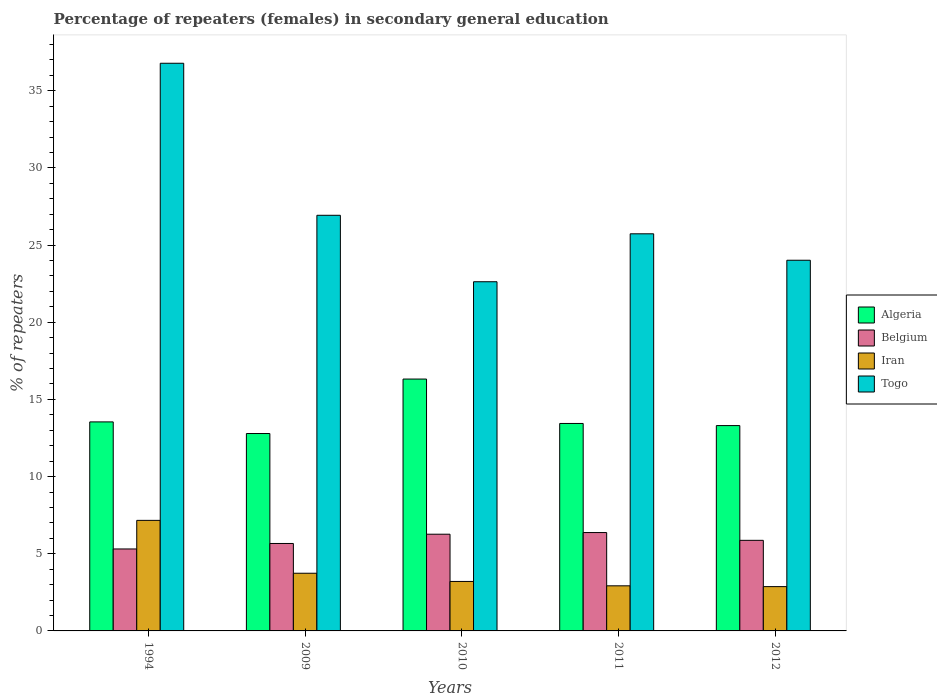How many different coloured bars are there?
Your answer should be very brief. 4. How many bars are there on the 2nd tick from the left?
Your response must be concise. 4. How many bars are there on the 5th tick from the right?
Give a very brief answer. 4. What is the percentage of female repeaters in Togo in 2010?
Your answer should be compact. 22.62. Across all years, what is the maximum percentage of female repeaters in Togo?
Make the answer very short. 36.78. Across all years, what is the minimum percentage of female repeaters in Togo?
Offer a very short reply. 22.62. What is the total percentage of female repeaters in Belgium in the graph?
Provide a short and direct response. 29.49. What is the difference between the percentage of female repeaters in Togo in 2010 and that in 2012?
Your answer should be very brief. -1.39. What is the difference between the percentage of female repeaters in Iran in 2011 and the percentage of female repeaters in Algeria in 1994?
Offer a terse response. -10.62. What is the average percentage of female repeaters in Iran per year?
Your answer should be compact. 3.98. In the year 2010, what is the difference between the percentage of female repeaters in Algeria and percentage of female repeaters in Togo?
Keep it short and to the point. -6.31. In how many years, is the percentage of female repeaters in Algeria greater than 29 %?
Provide a short and direct response. 0. What is the ratio of the percentage of female repeaters in Iran in 2010 to that in 2011?
Your answer should be very brief. 1.1. Is the difference between the percentage of female repeaters in Algeria in 2011 and 2012 greater than the difference between the percentage of female repeaters in Togo in 2011 and 2012?
Give a very brief answer. No. What is the difference between the highest and the second highest percentage of female repeaters in Togo?
Offer a very short reply. 9.85. What is the difference between the highest and the lowest percentage of female repeaters in Belgium?
Provide a succinct answer. 1.06. Is the sum of the percentage of female repeaters in Togo in 1994 and 2011 greater than the maximum percentage of female repeaters in Belgium across all years?
Your answer should be compact. Yes. Is it the case that in every year, the sum of the percentage of female repeaters in Algeria and percentage of female repeaters in Togo is greater than the sum of percentage of female repeaters in Belgium and percentage of female repeaters in Iran?
Your answer should be compact. No. What does the 4th bar from the left in 2010 represents?
Your answer should be very brief. Togo. What does the 2nd bar from the right in 1994 represents?
Make the answer very short. Iran. How many legend labels are there?
Offer a very short reply. 4. What is the title of the graph?
Your answer should be very brief. Percentage of repeaters (females) in secondary general education. Does "Caribbean small states" appear as one of the legend labels in the graph?
Give a very brief answer. No. What is the label or title of the Y-axis?
Offer a terse response. % of repeaters. What is the % of repeaters of Algeria in 1994?
Your answer should be very brief. 13.54. What is the % of repeaters in Belgium in 1994?
Provide a short and direct response. 5.31. What is the % of repeaters in Iran in 1994?
Provide a succinct answer. 7.16. What is the % of repeaters in Togo in 1994?
Offer a very short reply. 36.78. What is the % of repeaters of Algeria in 2009?
Your answer should be compact. 12.79. What is the % of repeaters of Belgium in 2009?
Ensure brevity in your answer.  5.67. What is the % of repeaters in Iran in 2009?
Ensure brevity in your answer.  3.74. What is the % of repeaters in Togo in 2009?
Offer a terse response. 26.93. What is the % of repeaters in Algeria in 2010?
Your answer should be compact. 16.32. What is the % of repeaters of Belgium in 2010?
Provide a succinct answer. 6.27. What is the % of repeaters in Iran in 2010?
Offer a very short reply. 3.21. What is the % of repeaters in Togo in 2010?
Your answer should be very brief. 22.62. What is the % of repeaters of Algeria in 2011?
Offer a terse response. 13.44. What is the % of repeaters in Belgium in 2011?
Your response must be concise. 6.37. What is the % of repeaters of Iran in 2011?
Keep it short and to the point. 2.92. What is the % of repeaters of Togo in 2011?
Provide a succinct answer. 25.73. What is the % of repeaters of Algeria in 2012?
Your answer should be very brief. 13.3. What is the % of repeaters of Belgium in 2012?
Provide a succinct answer. 5.87. What is the % of repeaters of Iran in 2012?
Provide a succinct answer. 2.87. What is the % of repeaters of Togo in 2012?
Give a very brief answer. 24.02. Across all years, what is the maximum % of repeaters in Algeria?
Offer a terse response. 16.32. Across all years, what is the maximum % of repeaters of Belgium?
Your answer should be compact. 6.37. Across all years, what is the maximum % of repeaters in Iran?
Your answer should be compact. 7.16. Across all years, what is the maximum % of repeaters in Togo?
Ensure brevity in your answer.  36.78. Across all years, what is the minimum % of repeaters of Algeria?
Make the answer very short. 12.79. Across all years, what is the minimum % of repeaters of Belgium?
Your response must be concise. 5.31. Across all years, what is the minimum % of repeaters of Iran?
Offer a very short reply. 2.87. Across all years, what is the minimum % of repeaters of Togo?
Your answer should be very brief. 22.62. What is the total % of repeaters in Algeria in the graph?
Keep it short and to the point. 69.4. What is the total % of repeaters in Belgium in the graph?
Your answer should be compact. 29.49. What is the total % of repeaters in Iran in the graph?
Keep it short and to the point. 19.9. What is the total % of repeaters in Togo in the graph?
Your answer should be compact. 136.08. What is the difference between the % of repeaters of Algeria in 1994 and that in 2009?
Make the answer very short. 0.75. What is the difference between the % of repeaters in Belgium in 1994 and that in 2009?
Give a very brief answer. -0.36. What is the difference between the % of repeaters of Iran in 1994 and that in 2009?
Offer a terse response. 3.43. What is the difference between the % of repeaters of Togo in 1994 and that in 2009?
Ensure brevity in your answer.  9.85. What is the difference between the % of repeaters of Algeria in 1994 and that in 2010?
Keep it short and to the point. -2.78. What is the difference between the % of repeaters in Belgium in 1994 and that in 2010?
Offer a very short reply. -0.96. What is the difference between the % of repeaters of Iran in 1994 and that in 2010?
Offer a terse response. 3.96. What is the difference between the % of repeaters of Togo in 1994 and that in 2010?
Provide a short and direct response. 14.16. What is the difference between the % of repeaters of Algeria in 1994 and that in 2011?
Give a very brief answer. 0.1. What is the difference between the % of repeaters in Belgium in 1994 and that in 2011?
Your answer should be very brief. -1.06. What is the difference between the % of repeaters in Iran in 1994 and that in 2011?
Provide a short and direct response. 4.24. What is the difference between the % of repeaters of Togo in 1994 and that in 2011?
Give a very brief answer. 11.05. What is the difference between the % of repeaters in Algeria in 1994 and that in 2012?
Make the answer very short. 0.24. What is the difference between the % of repeaters of Belgium in 1994 and that in 2012?
Your answer should be compact. -0.56. What is the difference between the % of repeaters of Iran in 1994 and that in 2012?
Keep it short and to the point. 4.29. What is the difference between the % of repeaters in Togo in 1994 and that in 2012?
Offer a terse response. 12.76. What is the difference between the % of repeaters in Algeria in 2009 and that in 2010?
Offer a very short reply. -3.53. What is the difference between the % of repeaters in Belgium in 2009 and that in 2010?
Ensure brevity in your answer.  -0.6. What is the difference between the % of repeaters of Iran in 2009 and that in 2010?
Provide a succinct answer. 0.53. What is the difference between the % of repeaters in Togo in 2009 and that in 2010?
Provide a short and direct response. 4.31. What is the difference between the % of repeaters of Algeria in 2009 and that in 2011?
Give a very brief answer. -0.65. What is the difference between the % of repeaters of Belgium in 2009 and that in 2011?
Offer a terse response. -0.71. What is the difference between the % of repeaters of Iran in 2009 and that in 2011?
Your answer should be compact. 0.82. What is the difference between the % of repeaters of Algeria in 2009 and that in 2012?
Give a very brief answer. -0.51. What is the difference between the % of repeaters of Belgium in 2009 and that in 2012?
Make the answer very short. -0.2. What is the difference between the % of repeaters in Iran in 2009 and that in 2012?
Keep it short and to the point. 0.87. What is the difference between the % of repeaters of Togo in 2009 and that in 2012?
Keep it short and to the point. 2.91. What is the difference between the % of repeaters of Algeria in 2010 and that in 2011?
Provide a succinct answer. 2.88. What is the difference between the % of repeaters in Belgium in 2010 and that in 2011?
Your answer should be very brief. -0.11. What is the difference between the % of repeaters of Iran in 2010 and that in 2011?
Offer a terse response. 0.28. What is the difference between the % of repeaters in Togo in 2010 and that in 2011?
Your response must be concise. -3.11. What is the difference between the % of repeaters in Algeria in 2010 and that in 2012?
Your answer should be compact. 3.01. What is the difference between the % of repeaters in Belgium in 2010 and that in 2012?
Keep it short and to the point. 0.4. What is the difference between the % of repeaters of Iran in 2010 and that in 2012?
Provide a short and direct response. 0.34. What is the difference between the % of repeaters in Togo in 2010 and that in 2012?
Your response must be concise. -1.39. What is the difference between the % of repeaters in Algeria in 2011 and that in 2012?
Give a very brief answer. 0.14. What is the difference between the % of repeaters in Belgium in 2011 and that in 2012?
Give a very brief answer. 0.5. What is the difference between the % of repeaters of Iran in 2011 and that in 2012?
Provide a short and direct response. 0.05. What is the difference between the % of repeaters in Togo in 2011 and that in 2012?
Give a very brief answer. 1.71. What is the difference between the % of repeaters of Algeria in 1994 and the % of repeaters of Belgium in 2009?
Your answer should be compact. 7.88. What is the difference between the % of repeaters of Algeria in 1994 and the % of repeaters of Iran in 2009?
Your response must be concise. 9.81. What is the difference between the % of repeaters in Algeria in 1994 and the % of repeaters in Togo in 2009?
Make the answer very short. -13.39. What is the difference between the % of repeaters in Belgium in 1994 and the % of repeaters in Iran in 2009?
Provide a succinct answer. 1.57. What is the difference between the % of repeaters in Belgium in 1994 and the % of repeaters in Togo in 2009?
Your answer should be very brief. -21.62. What is the difference between the % of repeaters of Iran in 1994 and the % of repeaters of Togo in 2009?
Your response must be concise. -19.77. What is the difference between the % of repeaters in Algeria in 1994 and the % of repeaters in Belgium in 2010?
Your response must be concise. 7.28. What is the difference between the % of repeaters of Algeria in 1994 and the % of repeaters of Iran in 2010?
Provide a short and direct response. 10.34. What is the difference between the % of repeaters in Algeria in 1994 and the % of repeaters in Togo in 2010?
Provide a short and direct response. -9.08. What is the difference between the % of repeaters in Belgium in 1994 and the % of repeaters in Iran in 2010?
Your answer should be compact. 2.1. What is the difference between the % of repeaters in Belgium in 1994 and the % of repeaters in Togo in 2010?
Provide a short and direct response. -17.31. What is the difference between the % of repeaters of Iran in 1994 and the % of repeaters of Togo in 2010?
Offer a very short reply. -15.46. What is the difference between the % of repeaters in Algeria in 1994 and the % of repeaters in Belgium in 2011?
Ensure brevity in your answer.  7.17. What is the difference between the % of repeaters in Algeria in 1994 and the % of repeaters in Iran in 2011?
Your response must be concise. 10.62. What is the difference between the % of repeaters in Algeria in 1994 and the % of repeaters in Togo in 2011?
Your answer should be compact. -12.19. What is the difference between the % of repeaters in Belgium in 1994 and the % of repeaters in Iran in 2011?
Offer a very short reply. 2.39. What is the difference between the % of repeaters in Belgium in 1994 and the % of repeaters in Togo in 2011?
Your answer should be compact. -20.42. What is the difference between the % of repeaters in Iran in 1994 and the % of repeaters in Togo in 2011?
Give a very brief answer. -18.57. What is the difference between the % of repeaters in Algeria in 1994 and the % of repeaters in Belgium in 2012?
Your answer should be compact. 7.67. What is the difference between the % of repeaters in Algeria in 1994 and the % of repeaters in Iran in 2012?
Your answer should be compact. 10.67. What is the difference between the % of repeaters in Algeria in 1994 and the % of repeaters in Togo in 2012?
Provide a succinct answer. -10.47. What is the difference between the % of repeaters in Belgium in 1994 and the % of repeaters in Iran in 2012?
Your answer should be compact. 2.44. What is the difference between the % of repeaters of Belgium in 1994 and the % of repeaters of Togo in 2012?
Provide a short and direct response. -18.71. What is the difference between the % of repeaters of Iran in 1994 and the % of repeaters of Togo in 2012?
Provide a short and direct response. -16.85. What is the difference between the % of repeaters of Algeria in 2009 and the % of repeaters of Belgium in 2010?
Make the answer very short. 6.52. What is the difference between the % of repeaters in Algeria in 2009 and the % of repeaters in Iran in 2010?
Your response must be concise. 9.58. What is the difference between the % of repeaters of Algeria in 2009 and the % of repeaters of Togo in 2010?
Your answer should be compact. -9.83. What is the difference between the % of repeaters in Belgium in 2009 and the % of repeaters in Iran in 2010?
Offer a very short reply. 2.46. What is the difference between the % of repeaters of Belgium in 2009 and the % of repeaters of Togo in 2010?
Ensure brevity in your answer.  -16.96. What is the difference between the % of repeaters in Iran in 2009 and the % of repeaters in Togo in 2010?
Your answer should be compact. -18.89. What is the difference between the % of repeaters of Algeria in 2009 and the % of repeaters of Belgium in 2011?
Keep it short and to the point. 6.42. What is the difference between the % of repeaters in Algeria in 2009 and the % of repeaters in Iran in 2011?
Your answer should be compact. 9.87. What is the difference between the % of repeaters of Algeria in 2009 and the % of repeaters of Togo in 2011?
Offer a very short reply. -12.94. What is the difference between the % of repeaters of Belgium in 2009 and the % of repeaters of Iran in 2011?
Give a very brief answer. 2.74. What is the difference between the % of repeaters of Belgium in 2009 and the % of repeaters of Togo in 2011?
Offer a very short reply. -20.06. What is the difference between the % of repeaters in Iran in 2009 and the % of repeaters in Togo in 2011?
Provide a succinct answer. -21.99. What is the difference between the % of repeaters in Algeria in 2009 and the % of repeaters in Belgium in 2012?
Your answer should be very brief. 6.92. What is the difference between the % of repeaters of Algeria in 2009 and the % of repeaters of Iran in 2012?
Your answer should be compact. 9.92. What is the difference between the % of repeaters in Algeria in 2009 and the % of repeaters in Togo in 2012?
Provide a short and direct response. -11.23. What is the difference between the % of repeaters in Belgium in 2009 and the % of repeaters in Iran in 2012?
Give a very brief answer. 2.8. What is the difference between the % of repeaters in Belgium in 2009 and the % of repeaters in Togo in 2012?
Offer a terse response. -18.35. What is the difference between the % of repeaters in Iran in 2009 and the % of repeaters in Togo in 2012?
Your answer should be compact. -20.28. What is the difference between the % of repeaters of Algeria in 2010 and the % of repeaters of Belgium in 2011?
Offer a terse response. 9.95. What is the difference between the % of repeaters of Algeria in 2010 and the % of repeaters of Iran in 2011?
Keep it short and to the point. 13.4. What is the difference between the % of repeaters in Algeria in 2010 and the % of repeaters in Togo in 2011?
Ensure brevity in your answer.  -9.41. What is the difference between the % of repeaters of Belgium in 2010 and the % of repeaters of Iran in 2011?
Offer a terse response. 3.34. What is the difference between the % of repeaters in Belgium in 2010 and the % of repeaters in Togo in 2011?
Your answer should be very brief. -19.46. What is the difference between the % of repeaters of Iran in 2010 and the % of repeaters of Togo in 2011?
Your answer should be compact. -22.52. What is the difference between the % of repeaters of Algeria in 2010 and the % of repeaters of Belgium in 2012?
Keep it short and to the point. 10.45. What is the difference between the % of repeaters in Algeria in 2010 and the % of repeaters in Iran in 2012?
Your response must be concise. 13.45. What is the difference between the % of repeaters in Algeria in 2010 and the % of repeaters in Togo in 2012?
Give a very brief answer. -7.7. What is the difference between the % of repeaters in Belgium in 2010 and the % of repeaters in Iran in 2012?
Ensure brevity in your answer.  3.4. What is the difference between the % of repeaters in Belgium in 2010 and the % of repeaters in Togo in 2012?
Offer a very short reply. -17.75. What is the difference between the % of repeaters in Iran in 2010 and the % of repeaters in Togo in 2012?
Offer a very short reply. -20.81. What is the difference between the % of repeaters of Algeria in 2011 and the % of repeaters of Belgium in 2012?
Keep it short and to the point. 7.57. What is the difference between the % of repeaters in Algeria in 2011 and the % of repeaters in Iran in 2012?
Offer a very short reply. 10.57. What is the difference between the % of repeaters of Algeria in 2011 and the % of repeaters of Togo in 2012?
Keep it short and to the point. -10.58. What is the difference between the % of repeaters in Belgium in 2011 and the % of repeaters in Iran in 2012?
Offer a terse response. 3.5. What is the difference between the % of repeaters in Belgium in 2011 and the % of repeaters in Togo in 2012?
Offer a very short reply. -17.64. What is the difference between the % of repeaters in Iran in 2011 and the % of repeaters in Togo in 2012?
Offer a very short reply. -21.1. What is the average % of repeaters of Algeria per year?
Provide a short and direct response. 13.88. What is the average % of repeaters in Belgium per year?
Provide a short and direct response. 5.9. What is the average % of repeaters of Iran per year?
Your answer should be very brief. 3.98. What is the average % of repeaters of Togo per year?
Keep it short and to the point. 27.22. In the year 1994, what is the difference between the % of repeaters of Algeria and % of repeaters of Belgium?
Keep it short and to the point. 8.23. In the year 1994, what is the difference between the % of repeaters of Algeria and % of repeaters of Iran?
Offer a terse response. 6.38. In the year 1994, what is the difference between the % of repeaters of Algeria and % of repeaters of Togo?
Give a very brief answer. -23.24. In the year 1994, what is the difference between the % of repeaters of Belgium and % of repeaters of Iran?
Your answer should be very brief. -1.85. In the year 1994, what is the difference between the % of repeaters in Belgium and % of repeaters in Togo?
Your response must be concise. -31.47. In the year 1994, what is the difference between the % of repeaters in Iran and % of repeaters in Togo?
Offer a very short reply. -29.62. In the year 2009, what is the difference between the % of repeaters in Algeria and % of repeaters in Belgium?
Offer a terse response. 7.12. In the year 2009, what is the difference between the % of repeaters of Algeria and % of repeaters of Iran?
Provide a succinct answer. 9.05. In the year 2009, what is the difference between the % of repeaters of Algeria and % of repeaters of Togo?
Your answer should be compact. -14.14. In the year 2009, what is the difference between the % of repeaters of Belgium and % of repeaters of Iran?
Provide a short and direct response. 1.93. In the year 2009, what is the difference between the % of repeaters in Belgium and % of repeaters in Togo?
Your response must be concise. -21.26. In the year 2009, what is the difference between the % of repeaters in Iran and % of repeaters in Togo?
Provide a short and direct response. -23.19. In the year 2010, what is the difference between the % of repeaters in Algeria and % of repeaters in Belgium?
Your response must be concise. 10.05. In the year 2010, what is the difference between the % of repeaters of Algeria and % of repeaters of Iran?
Your answer should be compact. 13.11. In the year 2010, what is the difference between the % of repeaters in Algeria and % of repeaters in Togo?
Offer a very short reply. -6.31. In the year 2010, what is the difference between the % of repeaters in Belgium and % of repeaters in Iran?
Your answer should be very brief. 3.06. In the year 2010, what is the difference between the % of repeaters in Belgium and % of repeaters in Togo?
Give a very brief answer. -16.36. In the year 2010, what is the difference between the % of repeaters of Iran and % of repeaters of Togo?
Keep it short and to the point. -19.42. In the year 2011, what is the difference between the % of repeaters of Algeria and % of repeaters of Belgium?
Offer a very short reply. 7.07. In the year 2011, what is the difference between the % of repeaters of Algeria and % of repeaters of Iran?
Ensure brevity in your answer.  10.52. In the year 2011, what is the difference between the % of repeaters of Algeria and % of repeaters of Togo?
Provide a short and direct response. -12.29. In the year 2011, what is the difference between the % of repeaters in Belgium and % of repeaters in Iran?
Provide a short and direct response. 3.45. In the year 2011, what is the difference between the % of repeaters in Belgium and % of repeaters in Togo?
Offer a terse response. -19.36. In the year 2011, what is the difference between the % of repeaters of Iran and % of repeaters of Togo?
Provide a succinct answer. -22.81. In the year 2012, what is the difference between the % of repeaters in Algeria and % of repeaters in Belgium?
Make the answer very short. 7.44. In the year 2012, what is the difference between the % of repeaters in Algeria and % of repeaters in Iran?
Offer a terse response. 10.43. In the year 2012, what is the difference between the % of repeaters of Algeria and % of repeaters of Togo?
Offer a terse response. -10.71. In the year 2012, what is the difference between the % of repeaters in Belgium and % of repeaters in Iran?
Provide a succinct answer. 3. In the year 2012, what is the difference between the % of repeaters of Belgium and % of repeaters of Togo?
Your answer should be compact. -18.15. In the year 2012, what is the difference between the % of repeaters of Iran and % of repeaters of Togo?
Provide a short and direct response. -21.15. What is the ratio of the % of repeaters of Algeria in 1994 to that in 2009?
Ensure brevity in your answer.  1.06. What is the ratio of the % of repeaters of Belgium in 1994 to that in 2009?
Provide a short and direct response. 0.94. What is the ratio of the % of repeaters of Iran in 1994 to that in 2009?
Give a very brief answer. 1.92. What is the ratio of the % of repeaters in Togo in 1994 to that in 2009?
Make the answer very short. 1.37. What is the ratio of the % of repeaters of Algeria in 1994 to that in 2010?
Ensure brevity in your answer.  0.83. What is the ratio of the % of repeaters of Belgium in 1994 to that in 2010?
Make the answer very short. 0.85. What is the ratio of the % of repeaters in Iran in 1994 to that in 2010?
Give a very brief answer. 2.23. What is the ratio of the % of repeaters of Togo in 1994 to that in 2010?
Give a very brief answer. 1.63. What is the ratio of the % of repeaters in Algeria in 1994 to that in 2011?
Keep it short and to the point. 1.01. What is the ratio of the % of repeaters of Belgium in 1994 to that in 2011?
Make the answer very short. 0.83. What is the ratio of the % of repeaters in Iran in 1994 to that in 2011?
Provide a succinct answer. 2.45. What is the ratio of the % of repeaters in Togo in 1994 to that in 2011?
Your answer should be compact. 1.43. What is the ratio of the % of repeaters in Algeria in 1994 to that in 2012?
Keep it short and to the point. 1.02. What is the ratio of the % of repeaters of Belgium in 1994 to that in 2012?
Your response must be concise. 0.9. What is the ratio of the % of repeaters of Iran in 1994 to that in 2012?
Make the answer very short. 2.5. What is the ratio of the % of repeaters of Togo in 1994 to that in 2012?
Offer a very short reply. 1.53. What is the ratio of the % of repeaters in Algeria in 2009 to that in 2010?
Provide a succinct answer. 0.78. What is the ratio of the % of repeaters of Belgium in 2009 to that in 2010?
Provide a short and direct response. 0.9. What is the ratio of the % of repeaters in Iran in 2009 to that in 2010?
Keep it short and to the point. 1.17. What is the ratio of the % of repeaters in Togo in 2009 to that in 2010?
Offer a terse response. 1.19. What is the ratio of the % of repeaters in Algeria in 2009 to that in 2011?
Offer a very short reply. 0.95. What is the ratio of the % of repeaters in Iran in 2009 to that in 2011?
Make the answer very short. 1.28. What is the ratio of the % of repeaters of Togo in 2009 to that in 2011?
Keep it short and to the point. 1.05. What is the ratio of the % of repeaters in Algeria in 2009 to that in 2012?
Give a very brief answer. 0.96. What is the ratio of the % of repeaters in Belgium in 2009 to that in 2012?
Ensure brevity in your answer.  0.97. What is the ratio of the % of repeaters of Iran in 2009 to that in 2012?
Offer a terse response. 1.3. What is the ratio of the % of repeaters of Togo in 2009 to that in 2012?
Provide a succinct answer. 1.12. What is the ratio of the % of repeaters of Algeria in 2010 to that in 2011?
Your answer should be very brief. 1.21. What is the ratio of the % of repeaters of Belgium in 2010 to that in 2011?
Your answer should be very brief. 0.98. What is the ratio of the % of repeaters in Iran in 2010 to that in 2011?
Provide a succinct answer. 1.1. What is the ratio of the % of repeaters in Togo in 2010 to that in 2011?
Keep it short and to the point. 0.88. What is the ratio of the % of repeaters in Algeria in 2010 to that in 2012?
Offer a very short reply. 1.23. What is the ratio of the % of repeaters of Belgium in 2010 to that in 2012?
Keep it short and to the point. 1.07. What is the ratio of the % of repeaters of Iran in 2010 to that in 2012?
Offer a very short reply. 1.12. What is the ratio of the % of repeaters of Togo in 2010 to that in 2012?
Provide a short and direct response. 0.94. What is the ratio of the % of repeaters in Algeria in 2011 to that in 2012?
Offer a terse response. 1.01. What is the ratio of the % of repeaters of Belgium in 2011 to that in 2012?
Keep it short and to the point. 1.09. What is the ratio of the % of repeaters in Togo in 2011 to that in 2012?
Your answer should be compact. 1.07. What is the difference between the highest and the second highest % of repeaters in Algeria?
Your answer should be very brief. 2.78. What is the difference between the highest and the second highest % of repeaters of Belgium?
Your answer should be compact. 0.11. What is the difference between the highest and the second highest % of repeaters of Iran?
Ensure brevity in your answer.  3.43. What is the difference between the highest and the second highest % of repeaters in Togo?
Your response must be concise. 9.85. What is the difference between the highest and the lowest % of repeaters in Algeria?
Your response must be concise. 3.53. What is the difference between the highest and the lowest % of repeaters of Belgium?
Ensure brevity in your answer.  1.06. What is the difference between the highest and the lowest % of repeaters in Iran?
Provide a succinct answer. 4.29. What is the difference between the highest and the lowest % of repeaters of Togo?
Provide a short and direct response. 14.16. 